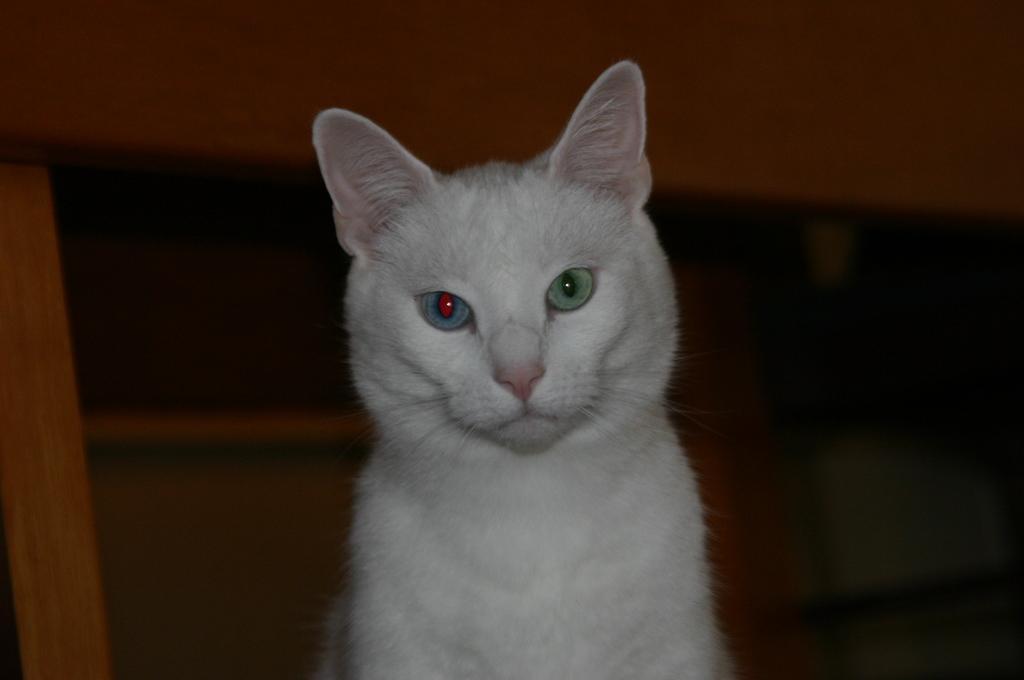How would you summarize this image in a sentence or two? In this image I can see a white colour cat. I can also see this image is little bit in dark from background. 